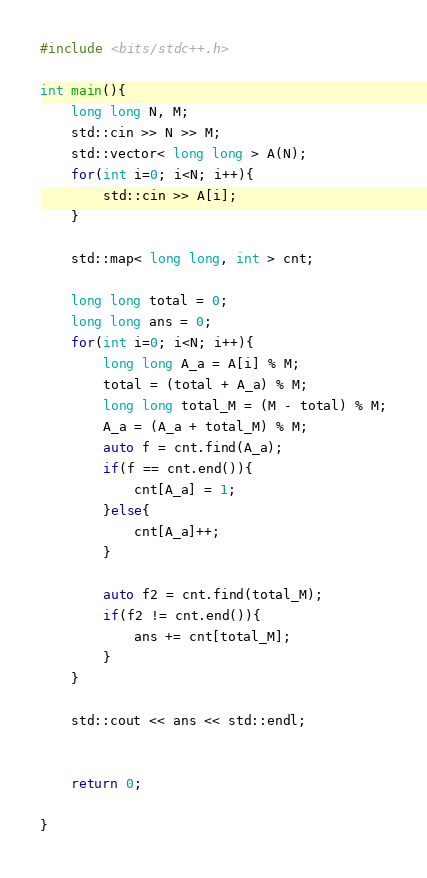Convert code to text. <code><loc_0><loc_0><loc_500><loc_500><_C++_>#include <bits/stdc++.h>

int main(){
    long long N, M;
    std::cin >> N >> M;
    std::vector< long long > A(N);
    for(int i=0; i<N; i++){
        std::cin >> A[i];
    }
    
    std::map< long long, int > cnt;
    
    long long total = 0;
    long long ans = 0;
    for(int i=0; i<N; i++){
        long long A_a = A[i] % M;
        total = (total + A_a) % M;
        long long total_M = (M - total) % M;
        A_a = (A_a + total_M) % M;
        auto f = cnt.find(A_a);
        if(f == cnt.end()){
            cnt[A_a] = 1;
        }else{
            cnt[A_a]++;
        }
        
        auto f2 = cnt.find(total_M);
        if(f2 != cnt.end()){
            ans += cnt[total_M];
        }
    }
    
    std::cout << ans << std::endl;
    
    
    return 0;
    
}
</code> 